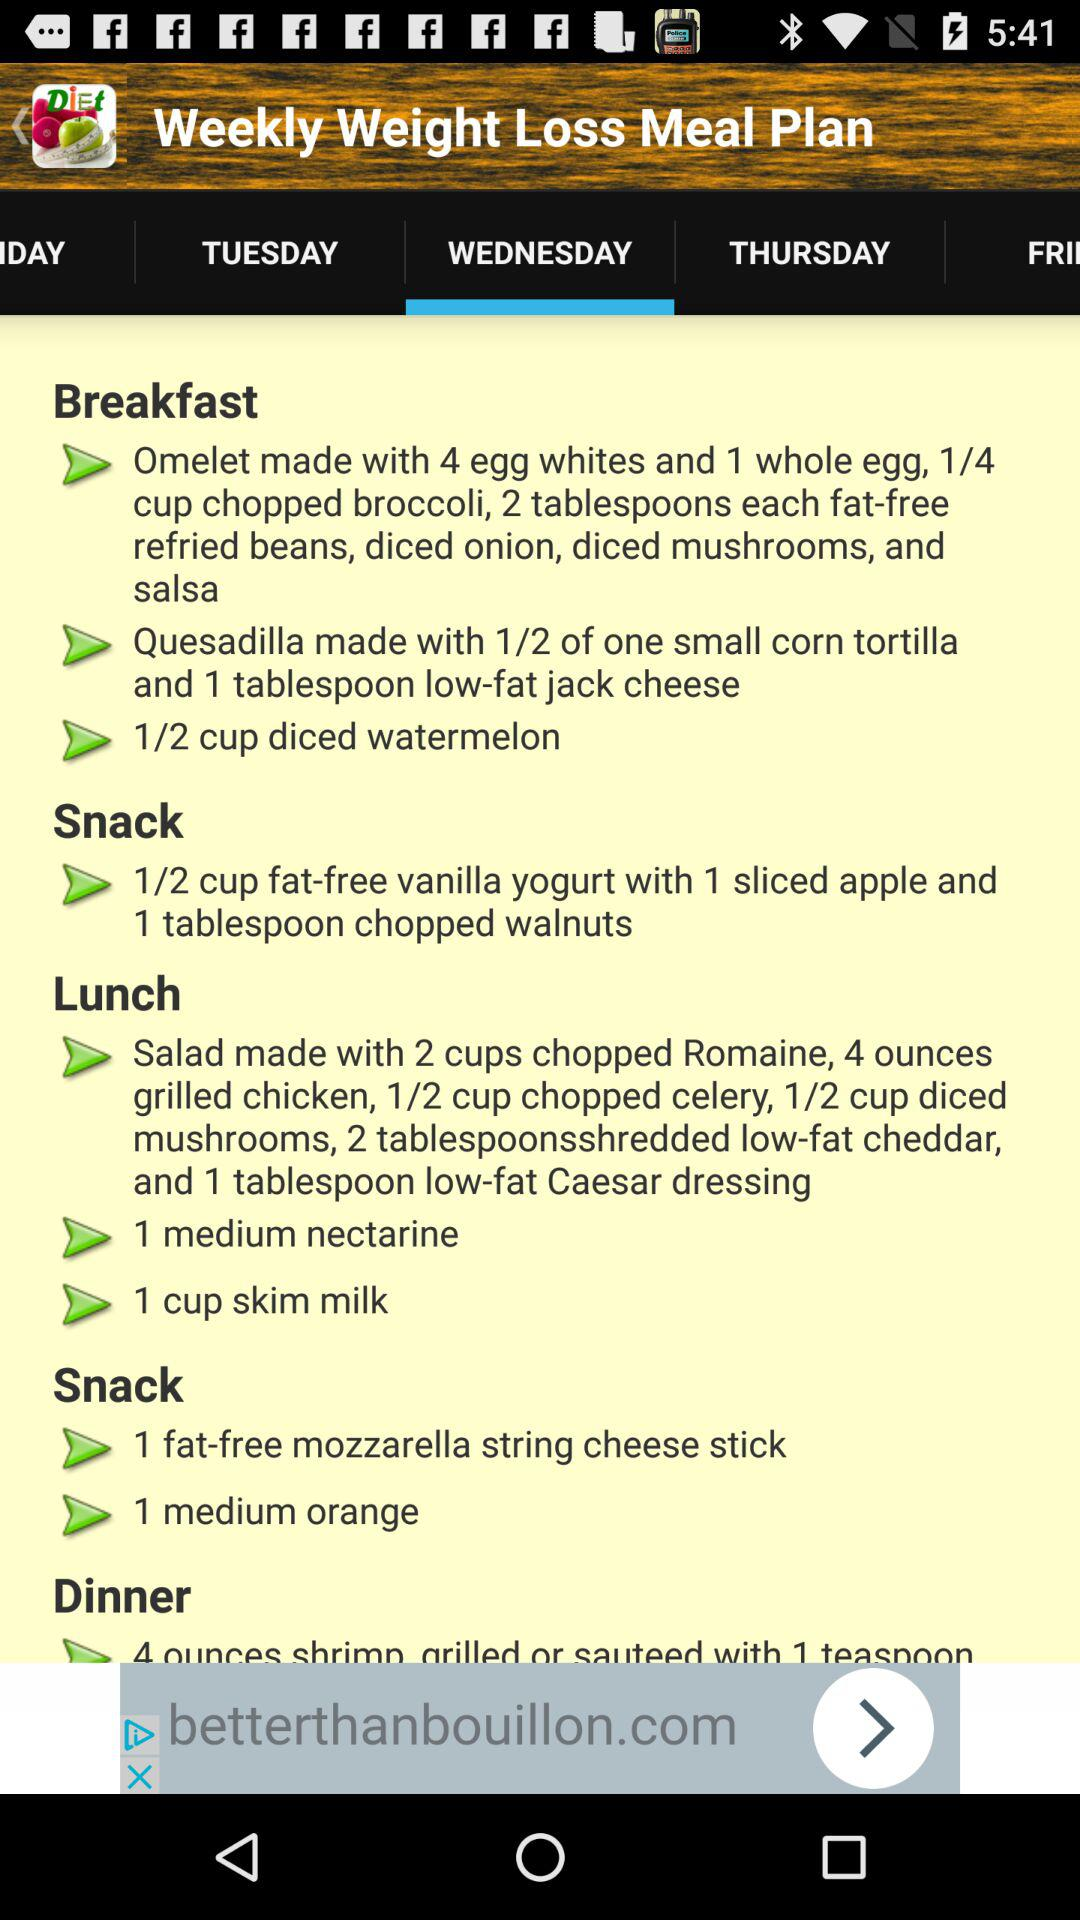Which day is selected? The selected day is Wednesday. 